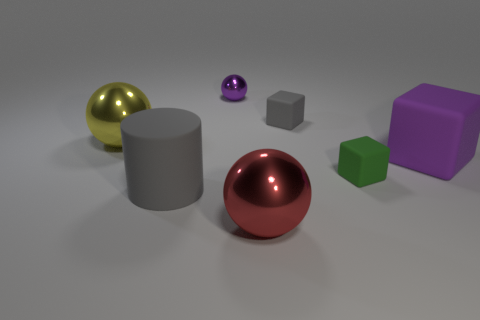Subtract all purple balls. Subtract all blue cubes. How many balls are left? 2 Add 1 tiny blue cubes. How many objects exist? 8 Subtract all cylinders. How many objects are left? 6 Subtract all small gray blocks. Subtract all cubes. How many objects are left? 3 Add 3 large gray objects. How many large gray objects are left? 4 Add 2 red shiny things. How many red shiny things exist? 3 Subtract 0 brown balls. How many objects are left? 7 